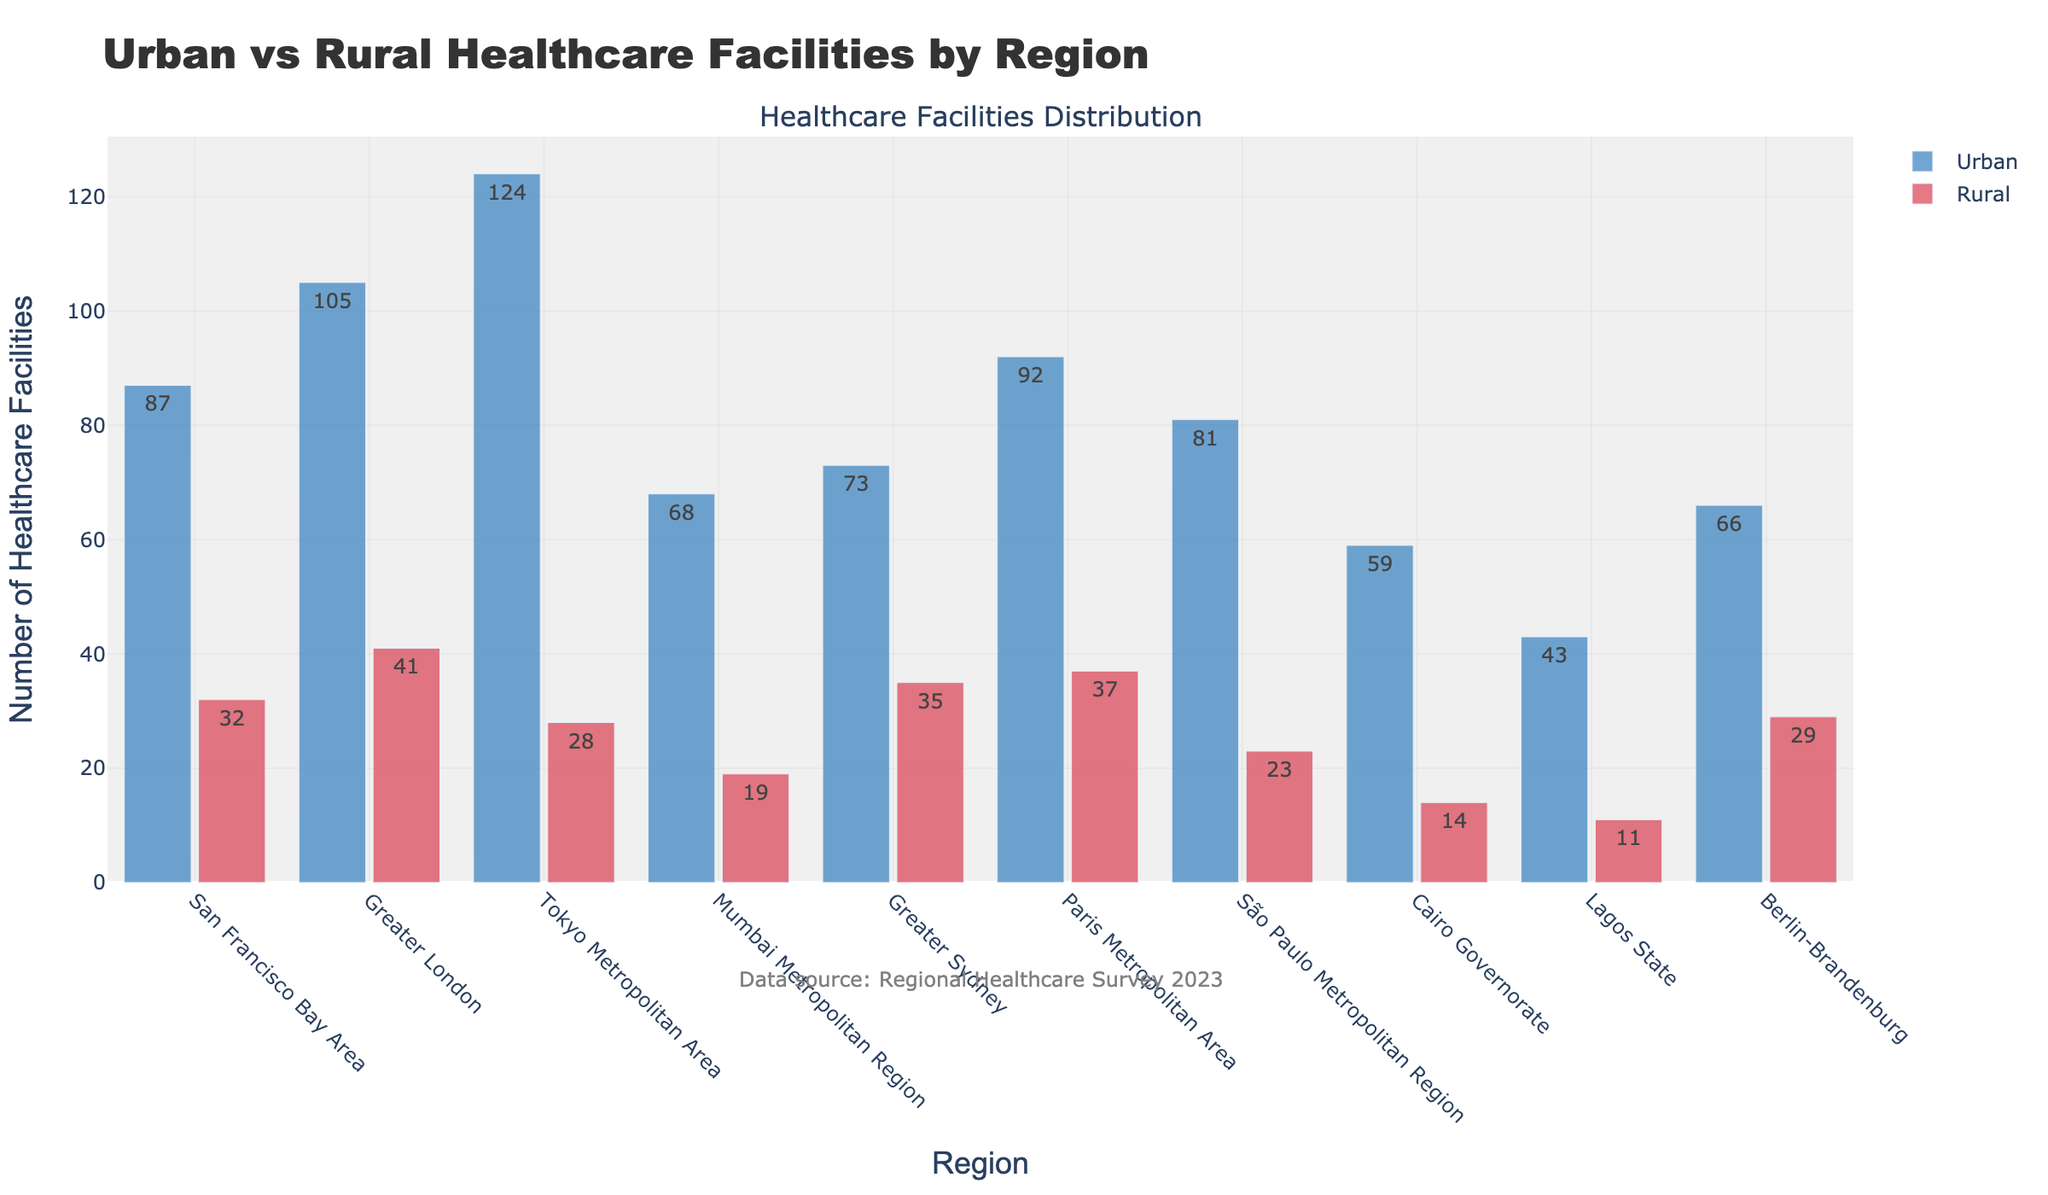Which region has the highest number of urban healthcare facilities? Looking at the figure, identify the bar representing urban healthcare facilities with the greatest height. This bar corresponds to the Tokyo Metropolitan Area.
Answer: Tokyo Metropolitan Area What is the difference in the number of urban and rural healthcare facilities in the San Francisco Bay Area? Identify the bars for the San Francisco Bay Area. The height of the urban bar is 87, and the rural bar is 32. The difference is 87 - 32.
Answer: 55 Which region has a greater number of rural healthcare facilities, Paris Metropolitan Area or Greater London? Compare the heights of the bars representing rural healthcare facilities for both regions. The Paris Metropolitan Area bar (37) is higher than the Greater London bar (41).
Answer: Greater London What is the total number of healthcare facilities (urban and rural combined) in the Greater Sydney region? Identify both the urban and rural bars for the Greater Sydney region. Sum the values: 73 (urban) + 35 (rural).
Answer: 108 How many more urban healthcare facilities does Mumbai Metropolitan Region have than Lagos State? Identify the bars for urban healthcare facilities in both regions: Mumbai Metropolitan Region (68) and Lagos State (43). The difference is: 68 - 43.
Answer: 25 Which region has the least number of rural healthcare facilities? Identify the shortest bar for rural healthcare facilities, corresponding to the Lagos State region.
Answer: Lagos State In which region do urban healthcare facilities outnumber rural healthcare facilities by the largest margin? For each region, calculate the difference between urban and rural healthcare facilities then compare the results. The Tokyo Metropolitan Area has the largest difference: 124 (urban) - 28 (rural) = 96.
Answer: Tokyo Metropolitan Area How many urban healthcare facilities are there in the Sāo Paulo Metropolitan Region? Find the urban healthcare bar for the Sāo Paulo Metropolitan Region. The height of this bar represents the number.
Answer: 81 Which two regions have an equal number of urban healthcare facilities? Examine the heights of the bars representing urban healthcare facilities and look for identical values. The regions with 66 facilities are Berlin-Brandenburg and Sāo Paulo Metropolitan Region.
Answer: Berlin-Brandenburg and Sāo Paulo Metropolitan Region What is the average number of rural healthcare facilities across all the regions? Sum the heights of all rural healthcare bars: 32 + 41 + 28 + 19 + 35 + 37 + 23 + 14 + 11 + 29 = 269. Divide by the number of regions (10): 269 / 10.
Answer: 26.9 